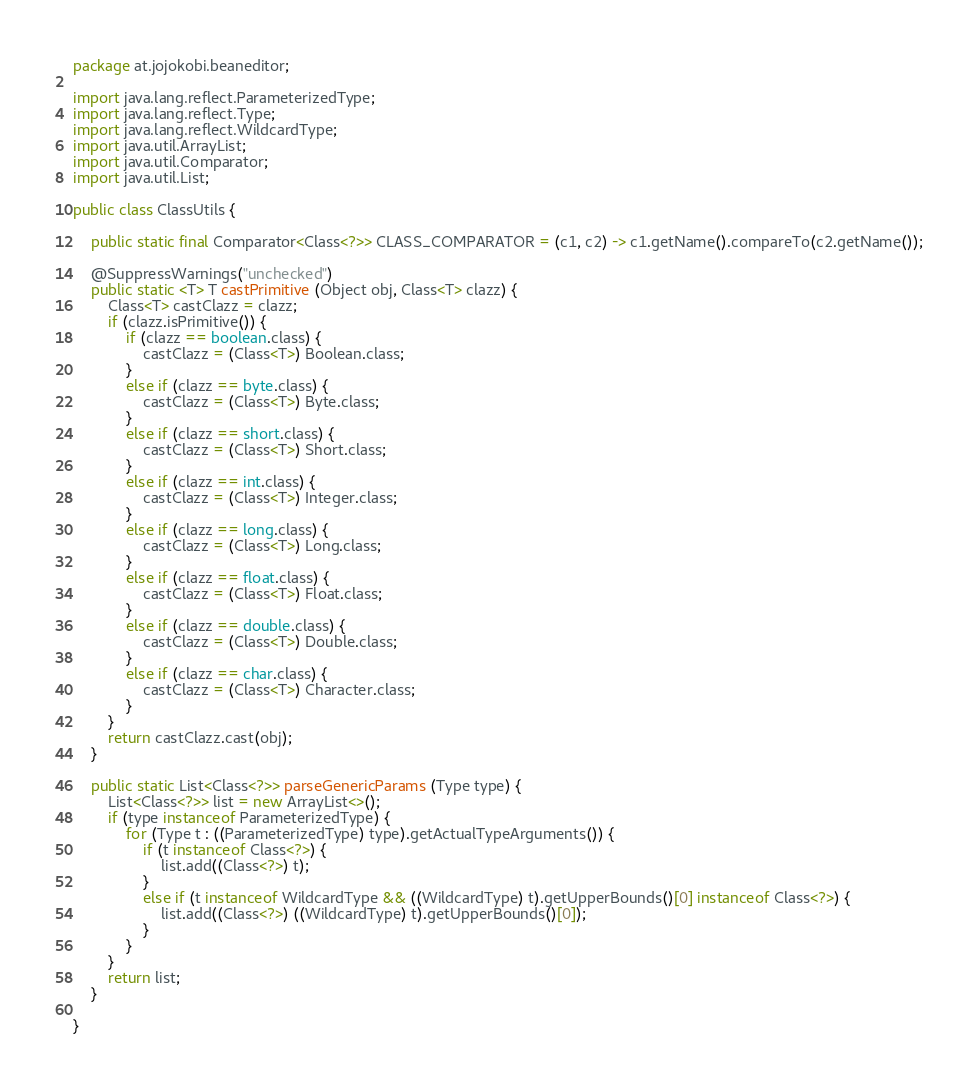Convert code to text. <code><loc_0><loc_0><loc_500><loc_500><_Java_>package at.jojokobi.beaneditor;

import java.lang.reflect.ParameterizedType;
import java.lang.reflect.Type;
import java.lang.reflect.WildcardType;
import java.util.ArrayList;
import java.util.Comparator;
import java.util.List;

public class ClassUtils {
	
	public static final Comparator<Class<?>> CLASS_COMPARATOR = (c1, c2) -> c1.getName().compareTo(c2.getName());

	@SuppressWarnings("unchecked")
	public static <T> T castPrimitive (Object obj, Class<T> clazz) {
		Class<T> castClazz = clazz;
		if (clazz.isPrimitive()) {
			if (clazz == boolean.class) {
				castClazz = (Class<T>) Boolean.class;
			}
			else if (clazz == byte.class) {
				castClazz = (Class<T>) Byte.class;
			}
			else if (clazz == short.class) {
				castClazz = (Class<T>) Short.class;
			}
			else if (clazz == int.class) {
				castClazz = (Class<T>) Integer.class;
			}
			else if (clazz == long.class) {
				castClazz = (Class<T>) Long.class;
			}
			else if (clazz == float.class) {
				castClazz = (Class<T>) Float.class;
			}
			else if (clazz == double.class) {
				castClazz = (Class<T>) Double.class;
			}
			else if (clazz == char.class) {
				castClazz = (Class<T>) Character.class;
			}
		}
		return castClazz.cast(obj);
	}
	
	public static List<Class<?>> parseGenericParams (Type type) {
		List<Class<?>> list = new ArrayList<>();
		if (type instanceof ParameterizedType) {
			for (Type t : ((ParameterizedType) type).getActualTypeArguments()) {
				if (t instanceof Class<?>) {
					list.add((Class<?>) t);
				}
				else if (t instanceof WildcardType && ((WildcardType) t).getUpperBounds()[0] instanceof Class<?>) {
					list.add((Class<?>) ((WildcardType) t).getUpperBounds()[0]);
				}
			}
		}
		return list;
	}
	
}
</code> 